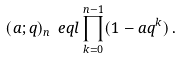<formula> <loc_0><loc_0><loc_500><loc_500>( a ; q ) _ { n } \ e q l \prod _ { k = 0 } ^ { n - 1 } ( 1 - a q ^ { k } ) \, .</formula> 